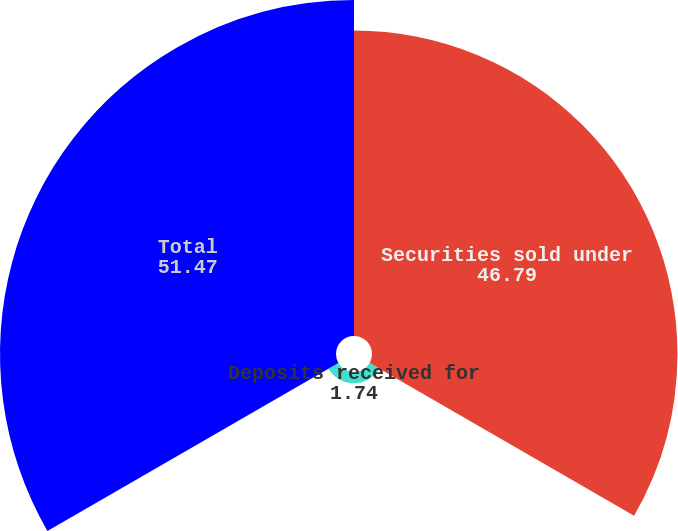<chart> <loc_0><loc_0><loc_500><loc_500><pie_chart><fcel>Securities sold under<fcel>Deposits received for<fcel>Total<nl><fcel>46.79%<fcel>1.74%<fcel>51.47%<nl></chart> 